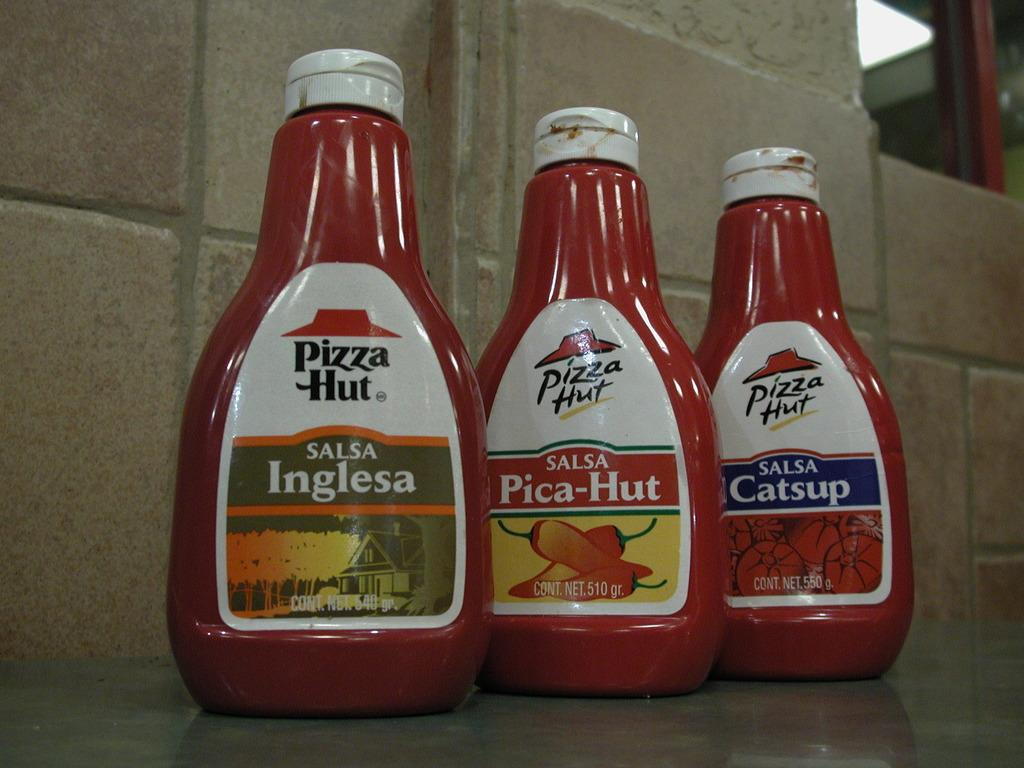<image>
Provide a brief description of the given image. Several Pizza Hut products are bottled and labeled. 